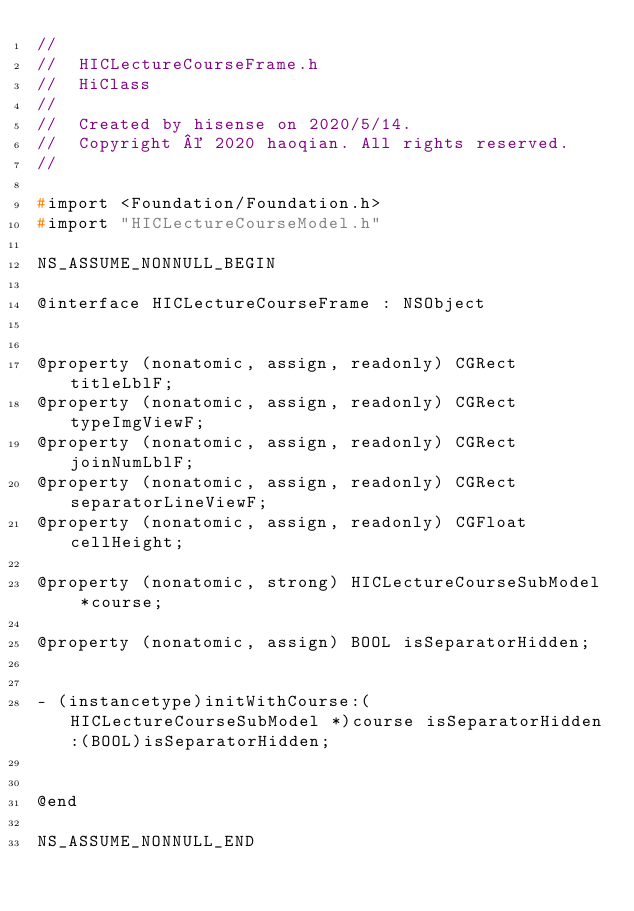Convert code to text. <code><loc_0><loc_0><loc_500><loc_500><_C_>//
//  HICLectureCourseFrame.h
//  HiClass
//
//  Created by hisense on 2020/5/14.
//  Copyright © 2020 haoqian. All rights reserved.
//

#import <Foundation/Foundation.h>
#import "HICLectureCourseModel.h"

NS_ASSUME_NONNULL_BEGIN

@interface HICLectureCourseFrame : NSObject


@property (nonatomic, assign, readonly) CGRect titleLblF;
@property (nonatomic, assign, readonly) CGRect typeImgViewF;
@property (nonatomic, assign, readonly) CGRect joinNumLblF;
@property (nonatomic, assign, readonly) CGRect separatorLineViewF;
@property (nonatomic, assign, readonly) CGFloat cellHeight;

@property (nonatomic, strong) HICLectureCourseSubModel *course;

@property (nonatomic, assign) BOOL isSeparatorHidden;


- (instancetype)initWithCourse:(HICLectureCourseSubModel *)course isSeparatorHidden:(BOOL)isSeparatorHidden;


@end

NS_ASSUME_NONNULL_END
</code> 